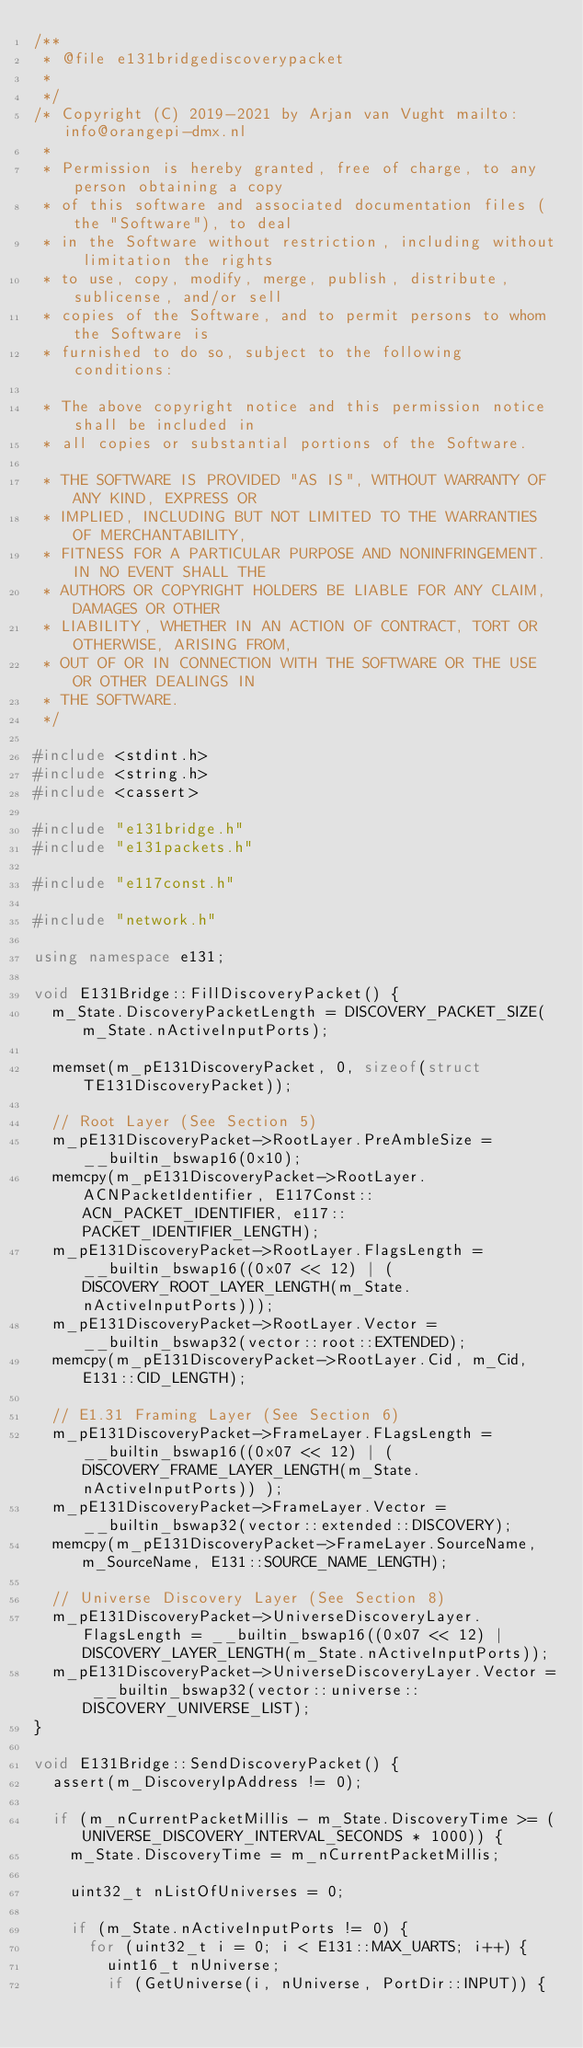Convert code to text. <code><loc_0><loc_0><loc_500><loc_500><_C++_>/**
 * @file e131bridgediscoverypacket
 *
 */
/* Copyright (C) 2019-2021 by Arjan van Vught mailto:info@orangepi-dmx.nl
 *
 * Permission is hereby granted, free of charge, to any person obtaining a copy
 * of this software and associated documentation files (the "Software"), to deal
 * in the Software without restriction, including without limitation the rights
 * to use, copy, modify, merge, publish, distribute, sublicense, and/or sell
 * copies of the Software, and to permit persons to whom the Software is
 * furnished to do so, subject to the following conditions:

 * The above copyright notice and this permission notice shall be included in
 * all copies or substantial portions of the Software.

 * THE SOFTWARE IS PROVIDED "AS IS", WITHOUT WARRANTY OF ANY KIND, EXPRESS OR
 * IMPLIED, INCLUDING BUT NOT LIMITED TO THE WARRANTIES OF MERCHANTABILITY,
 * FITNESS FOR A PARTICULAR PURPOSE AND NONINFRINGEMENT. IN NO EVENT SHALL THE
 * AUTHORS OR COPYRIGHT HOLDERS BE LIABLE FOR ANY CLAIM, DAMAGES OR OTHER
 * LIABILITY, WHETHER IN AN ACTION OF CONTRACT, TORT OR OTHERWISE, ARISING FROM,
 * OUT OF OR IN CONNECTION WITH THE SOFTWARE OR THE USE OR OTHER DEALINGS IN
 * THE SOFTWARE.
 */

#include <stdint.h>
#include <string.h>
#include <cassert>

#include "e131bridge.h"
#include "e131packets.h"

#include "e117const.h"

#include "network.h"

using namespace e131;

void E131Bridge::FillDiscoveryPacket() {
	m_State.DiscoveryPacketLength = DISCOVERY_PACKET_SIZE(m_State.nActiveInputPorts);

	memset(m_pE131DiscoveryPacket, 0, sizeof(struct TE131DiscoveryPacket));

	// Root Layer (See Section 5)
	m_pE131DiscoveryPacket->RootLayer.PreAmbleSize = __builtin_bswap16(0x10);
	memcpy(m_pE131DiscoveryPacket->RootLayer.ACNPacketIdentifier, E117Const::ACN_PACKET_IDENTIFIER, e117::PACKET_IDENTIFIER_LENGTH);
	m_pE131DiscoveryPacket->RootLayer.FlagsLength = __builtin_bswap16((0x07 << 12) | (DISCOVERY_ROOT_LAYER_LENGTH(m_State.nActiveInputPorts)));
	m_pE131DiscoveryPacket->RootLayer.Vector = __builtin_bswap32(vector::root::EXTENDED);
	memcpy(m_pE131DiscoveryPacket->RootLayer.Cid, m_Cid, E131::CID_LENGTH);

	// E1.31 Framing Layer (See Section 6)
	m_pE131DiscoveryPacket->FrameLayer.FLagsLength = __builtin_bswap16((0x07 << 12) | (DISCOVERY_FRAME_LAYER_LENGTH(m_State.nActiveInputPorts)) );
	m_pE131DiscoveryPacket->FrameLayer.Vector = __builtin_bswap32(vector::extended::DISCOVERY);
	memcpy(m_pE131DiscoveryPacket->FrameLayer.SourceName, m_SourceName, E131::SOURCE_NAME_LENGTH);

	// Universe Discovery Layer (See Section 8)
	m_pE131DiscoveryPacket->UniverseDiscoveryLayer.FlagsLength = __builtin_bswap16((0x07 << 12) | DISCOVERY_LAYER_LENGTH(m_State.nActiveInputPorts));
	m_pE131DiscoveryPacket->UniverseDiscoveryLayer.Vector = __builtin_bswap32(vector::universe::DISCOVERY_UNIVERSE_LIST);
}

void E131Bridge::SendDiscoveryPacket() {
	assert(m_DiscoveryIpAddress != 0);

	if (m_nCurrentPacketMillis - m_State.DiscoveryTime >= (UNIVERSE_DISCOVERY_INTERVAL_SECONDS * 1000)) {
		m_State.DiscoveryTime = m_nCurrentPacketMillis;

		uint32_t nListOfUniverses = 0;

		if (m_State.nActiveInputPorts != 0) {
			for (uint32_t i = 0; i < E131::MAX_UARTS; i++) {
				uint16_t nUniverse;
				if (GetUniverse(i, nUniverse, PortDir::INPUT)) {</code> 